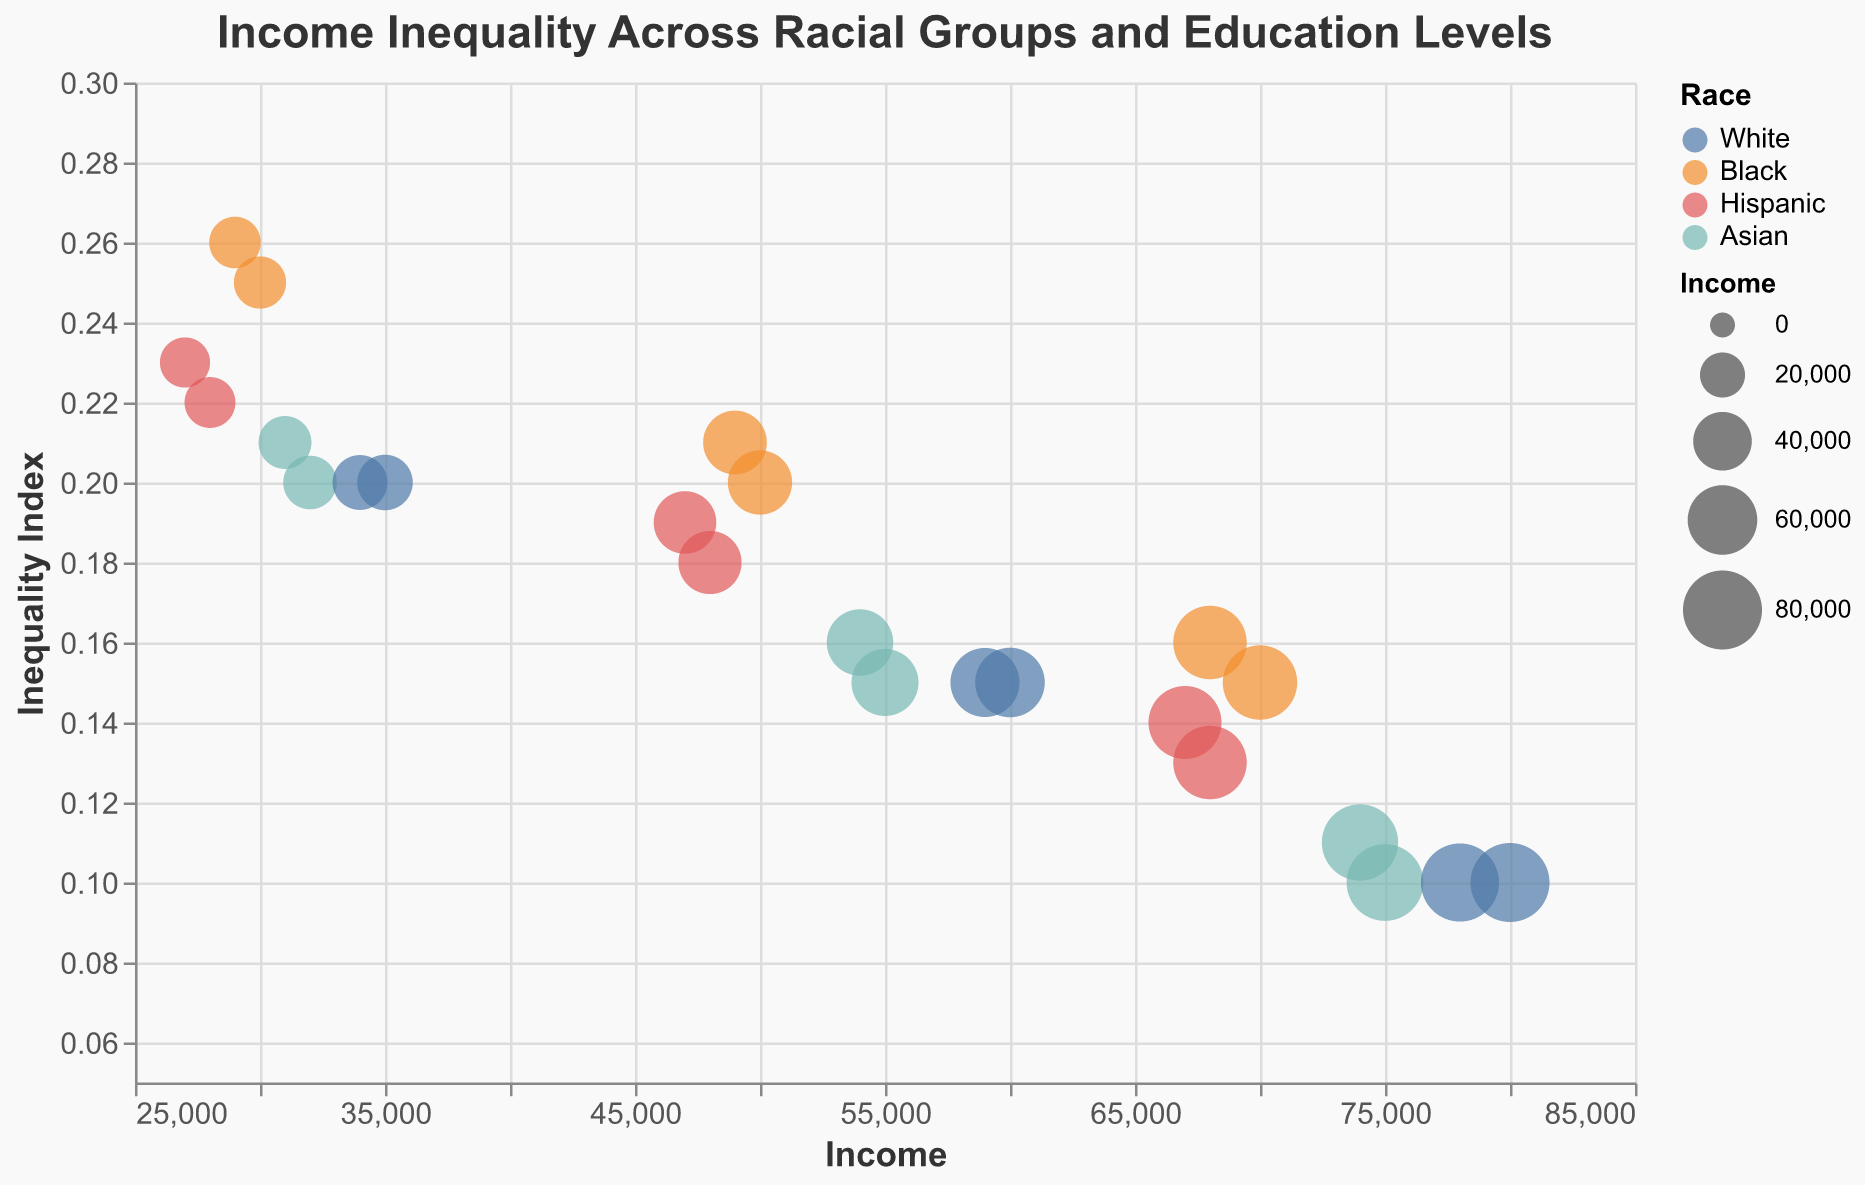What is the title of the figure? The title is located at the top of the figure and typically summarizes the content of the visualization.
Answer: Income Inequality Across Racial Groups and Education Levels How many racial groups are displayed in the bubble chart? The legend shows the categories for the Race variable, which indicates the number of distinct racial groups.
Answer: Four Which racial group has the highest income for people with a Master's Degree in New York? Look at the X-axis (Income) and the shape legend to find the bubbles representing each racial group with a Master's Degree. Then, identify the bubble with the highest income value.
Answer: White Which group and education level in Los Angeles has the highest inequality index? Look at the Y-axis (Inequality) and locate the highest point in the Los Angeles subset. Check the color (Race) and the shape (Education) of the corresponding bubble.
Answer: Black, High School Compare the income inequality of Hispanics with a Bachelor's Degree in New York to Los Angeles. Which city has a higher inequality for this group and education level? Locate the bubbles representing Hispanics with a Bachelor's Degree in both cities by their color and shape. Compare their positions on the Y-axis (Inequality).
Answer: Los Angeles What is the income difference between Asians with a Bachelor's Degree and Asians with a High School education in New York? Find the corresponding values for Asians with the specified education levels in New York and subtract the incomes: $55,000 - $32,000.
Answer: $23,000 Which racial group experiences the largest increase in income when moving from a High School education to a Bachelor's Degree in Los Angeles? Calculate the income difference for each racial group between the two education levels in Los Angeles. Identify the largest increase.
Answer: Black How does the inequality index change with higher education within the Black racial group in New York? Track the bubbles specific to the Black racial group in New York across different education levels by the shape, and observe the trend on the Y-axis (Inequality).
Answer: It decreases Which city's income inequality is higher overall for Whites with a Master's Degree? Compare the position of the bubbles representing Whites with a Master's Degree in both cities on the Y-axis (Inequality).
Answer: Los Angeles 